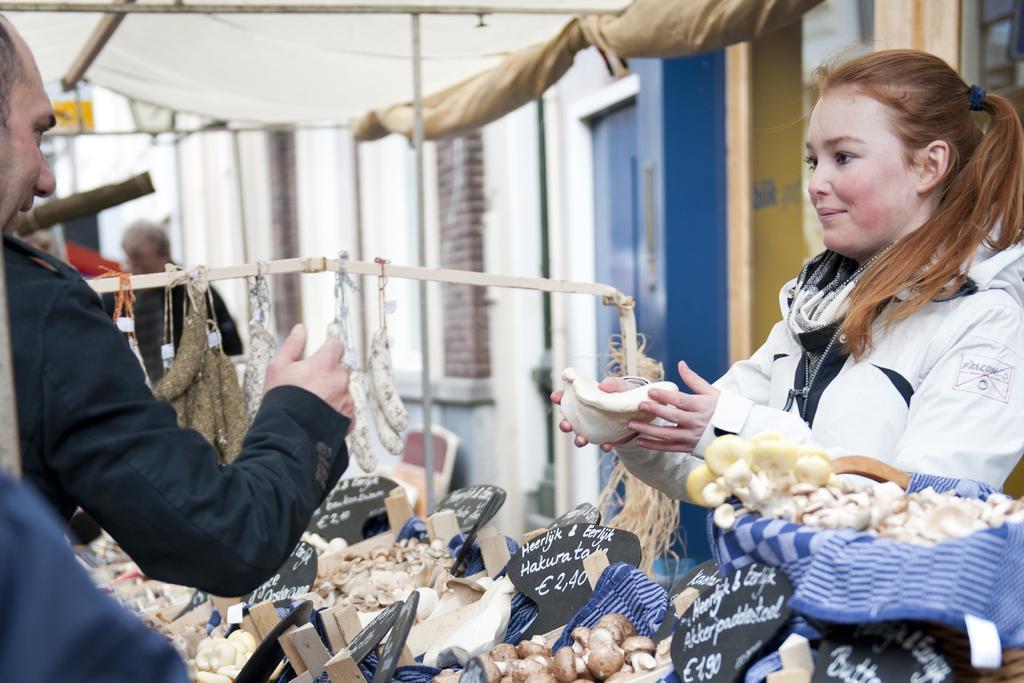Describe this image in one or two sentences. On the left side of the image there is a stall and there is a person standing. On the right side there is a girl holding an object in her hand. In the background there are buildings. 